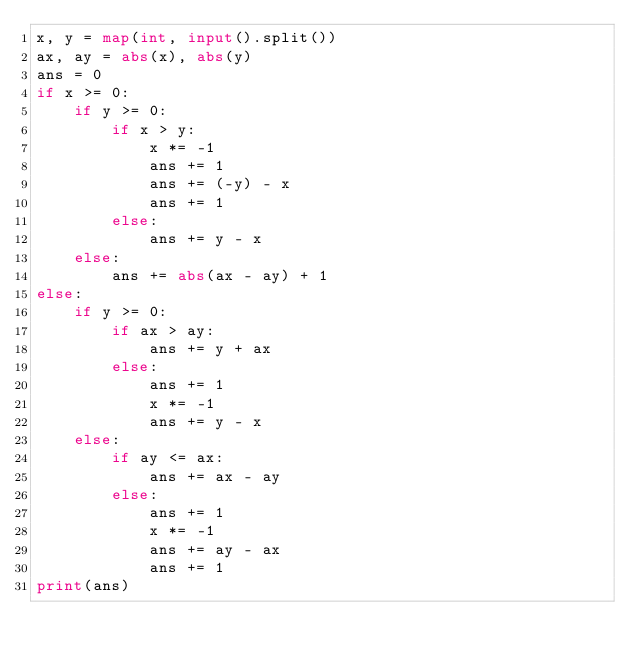<code> <loc_0><loc_0><loc_500><loc_500><_Python_>x, y = map(int, input().split())
ax, ay = abs(x), abs(y)
ans = 0
if x >= 0:
    if y >= 0:
        if x > y:
            x *= -1
            ans += 1
            ans += (-y) - x
            ans += 1
        else:
            ans += y - x
    else:
        ans += abs(ax - ay) + 1
else:
    if y >= 0:
        if ax > ay:
            ans += y + ax
        else:
            ans += 1
            x *= -1
            ans += y - x
    else:
        if ay <= ax:
            ans += ax - ay
        else:
            ans += 1
            x *= -1
            ans += ay - ax
            ans += 1
print(ans)
</code> 